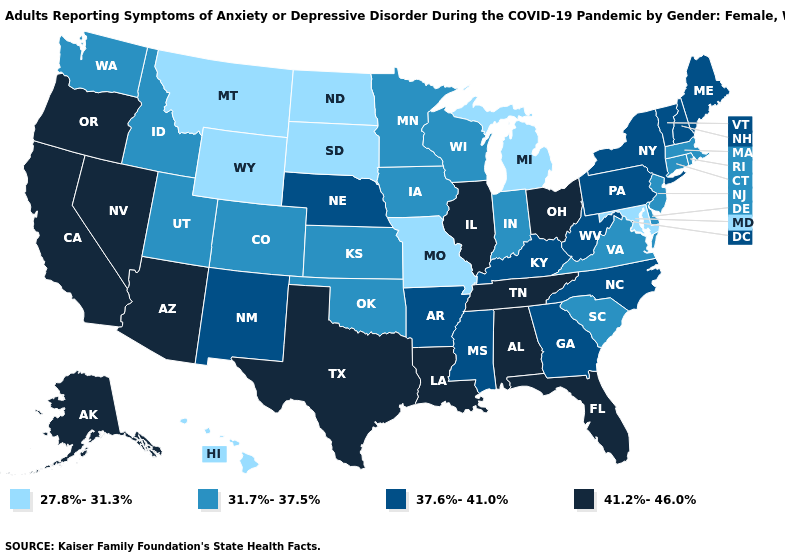Which states have the highest value in the USA?
Keep it brief. Alabama, Alaska, Arizona, California, Florida, Illinois, Louisiana, Nevada, Ohio, Oregon, Tennessee, Texas. Name the states that have a value in the range 41.2%-46.0%?
Short answer required. Alabama, Alaska, Arizona, California, Florida, Illinois, Louisiana, Nevada, Ohio, Oregon, Tennessee, Texas. Among the states that border Georgia , which have the highest value?
Concise answer only. Alabama, Florida, Tennessee. Does Georgia have the lowest value in the South?
Short answer required. No. Which states hav the highest value in the South?
Keep it brief. Alabama, Florida, Louisiana, Tennessee, Texas. Name the states that have a value in the range 41.2%-46.0%?
Be succinct. Alabama, Alaska, Arizona, California, Florida, Illinois, Louisiana, Nevada, Ohio, Oregon, Tennessee, Texas. Among the states that border Alabama , which have the lowest value?
Be succinct. Georgia, Mississippi. Does Montana have the lowest value in the West?
Short answer required. Yes. Among the states that border New York , does Vermont have the lowest value?
Short answer required. No. Does Oregon have the highest value in the West?
Answer briefly. Yes. What is the value of Idaho?
Short answer required. 31.7%-37.5%. Name the states that have a value in the range 41.2%-46.0%?
Short answer required. Alabama, Alaska, Arizona, California, Florida, Illinois, Louisiana, Nevada, Ohio, Oregon, Tennessee, Texas. Does California have the highest value in the USA?
Short answer required. Yes. What is the value of Mississippi?
Give a very brief answer. 37.6%-41.0%. 